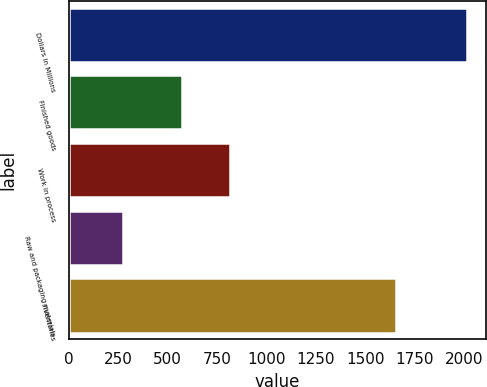Convert chart to OTSL. <chart><loc_0><loc_0><loc_500><loc_500><bar_chart><fcel>Dollars in Millions<fcel>Finished goods<fcel>Work in process<fcel>Raw and packaging materials<fcel>Inventories<nl><fcel>2012<fcel>572<fcel>814<fcel>271<fcel>1657<nl></chart> 